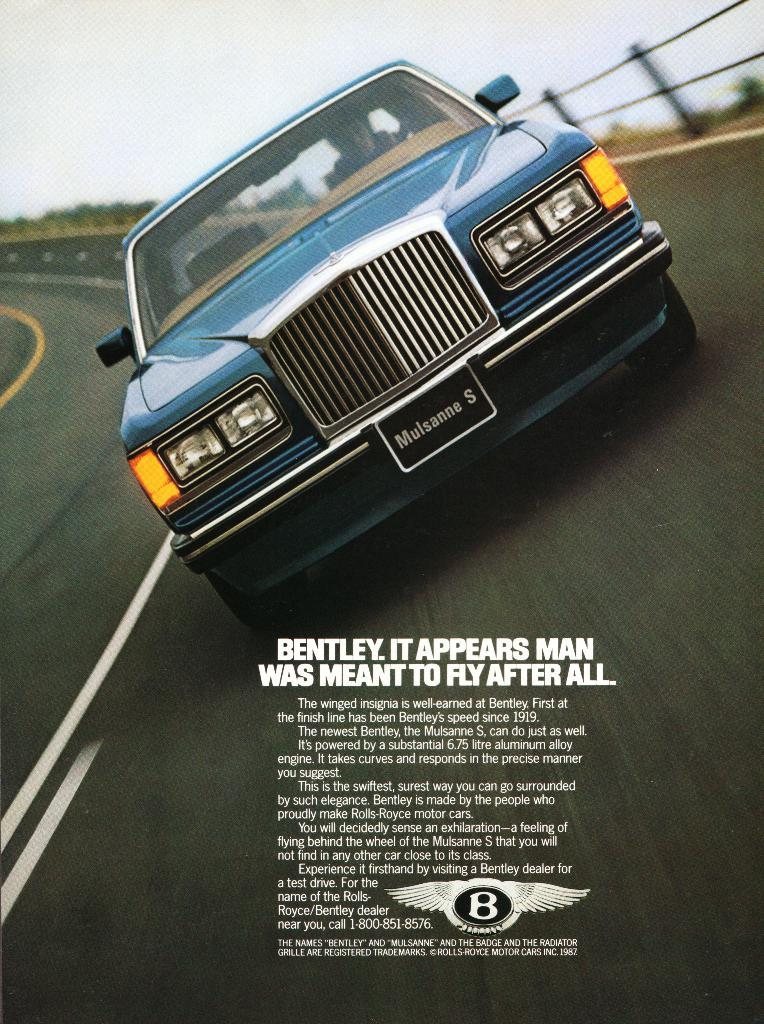What is the main subject of the image? The main subject of the image is a car. Where is the car located in the image? The car is on the road in the image. What is written or displayed at the bottom of the image? There is text at the bottom of the image. What can be seen above the car in the image? The sky is visible at the top of the image. How many balls are visible in the image? There are no balls present in the image. What type of work is being done by the car in the image? The image does not depict the car performing any work; it is simply located on the road. 